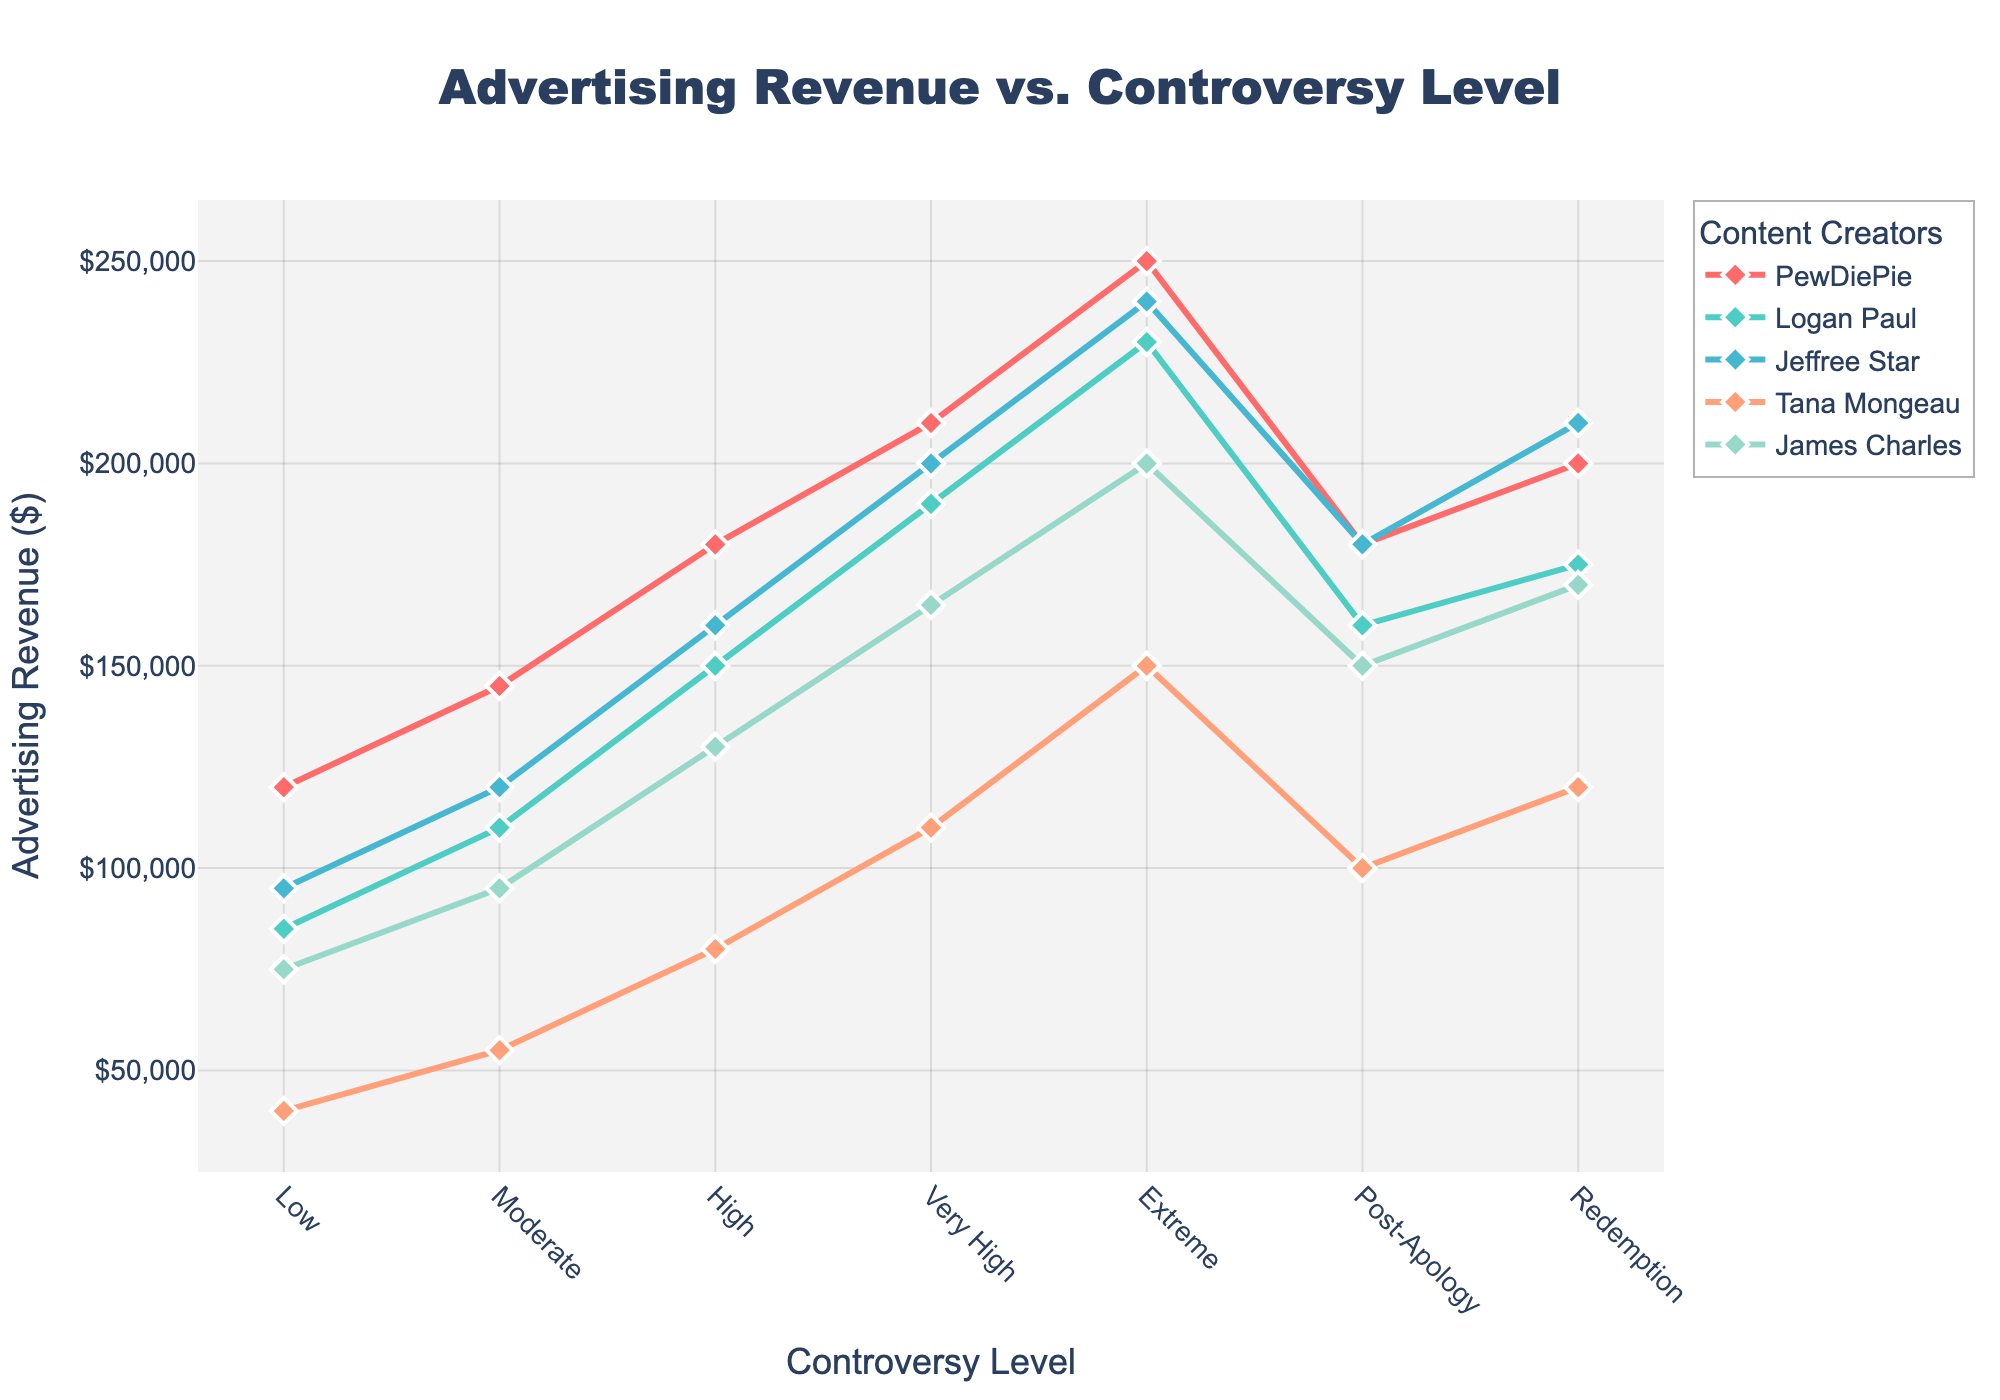What is the advertising revenue for James Charles at the 'High' controversy level? The line representing James Charles intersects with the y-axis at the 'High' controversy level. This intersection shows the value of advertising revenue.
Answer: 130,000 Which influencer has the highest advertising revenue at the 'Low' controversy level? Compare the y-values of all the influencers at the 'Low' controversy level. PewDiePie has the highest value.
Answer: PewDiePie What is the difference in advertising revenue between 'Extreme' and 'Post-Apology' levels for Logan Paul? Subtract Logan Paul's revenue at 'Post-Apology' level from his revenue at the 'Extreme' level: 230,000 - 160,000.
Answer: 70,000 At which controversy level does Tana Mongeau have the lowest advertising revenue? Identify the lowest point on Tana Mongeau's line across all controversy levels.
Answer: Low Compare Jeffree Star's revenue between 'Moderate' and 'Very High' controversy levels. Which one is higher and by how much? Find the revenue values for both levels and subtract the 'Moderate' value from the 'Very High' value: 200,000 - 120,000.
Answer: Very High by 80,000 Which influencer shows a decline in revenue from 'Extreme' to 'Post-Apology' level? Identify the lines that slope downward between 'Extreme' and 'Post-Apology' levels. All influencers have downward slopes, so they all show a decline.
Answer: All influencers What's the combined advertising revenue of all influencers at the 'Moderate' controversy level? Sum the advertising revenues of all influencers at 'Moderate' level: 145,000 + 110,000 + 120,000 + 55,000 + 95,000.
Answer: 525,000 How does the revenue for the 'Redemption' level compare across all influencers? Compare the y-values at the 'Redemption' level. PewDiePie has the highest, followed by Jeffree Star, Logan Paul, James Charles, and Tana Mongeau.
Answer: PewDiePie has the highest Which influencer shows the most stable trend in advertising revenue despite controversy level changes? Look for the flattest line with minimal fluctuations.
Answer: Tana Mongeau 